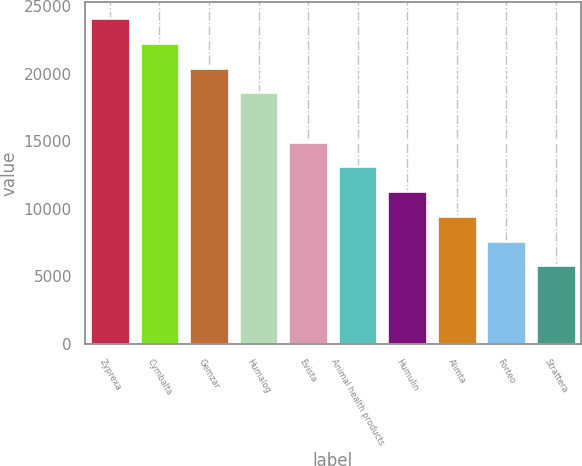<chart> <loc_0><loc_0><loc_500><loc_500><bar_chart><fcel>Zyprexa<fcel>Cymbalta<fcel>Gemzar<fcel>Humalog<fcel>Evista<fcel>Animal health products<fcel>Humulin<fcel>Alimta<fcel>Forteo<fcel>Strattera<nl><fcel>24124.3<fcel>22294.1<fcel>20463.8<fcel>18633.5<fcel>14972.9<fcel>13142.7<fcel>11312.4<fcel>9482.1<fcel>7651.82<fcel>5821.54<nl></chart> 